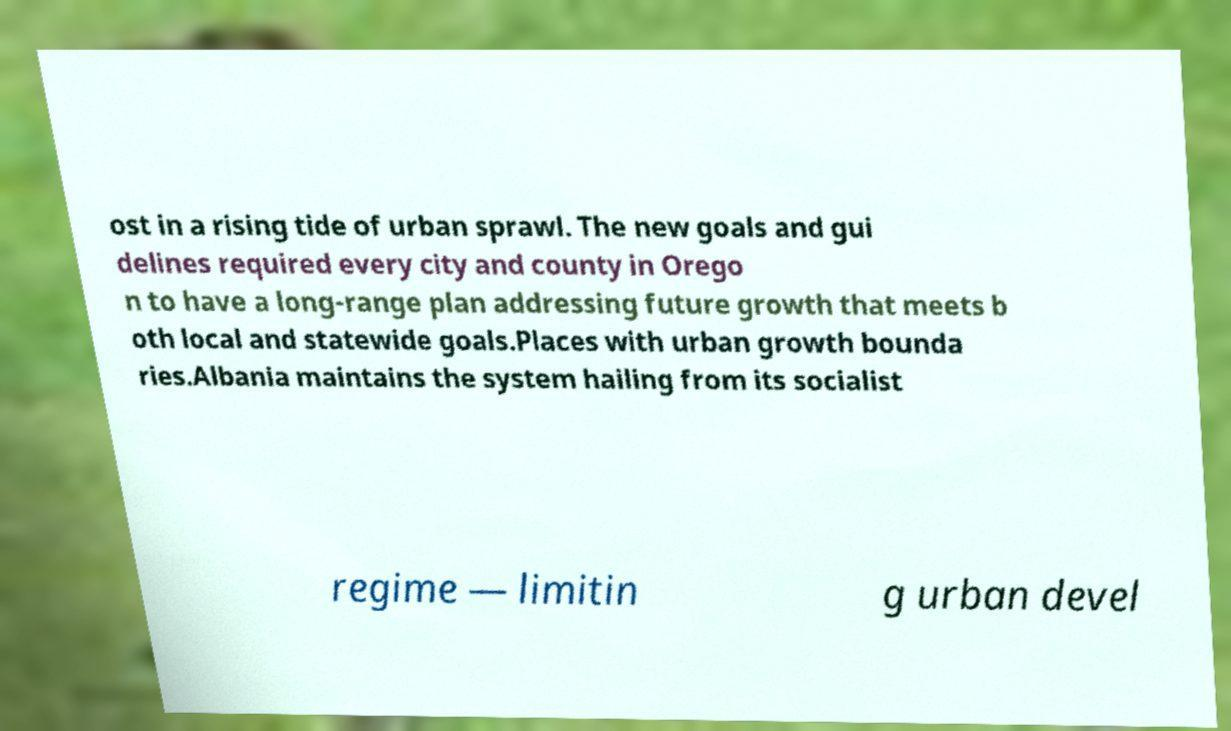What messages or text are displayed in this image? I need them in a readable, typed format. ost in a rising tide of urban sprawl. The new goals and gui delines required every city and county in Orego n to have a long-range plan addressing future growth that meets b oth local and statewide goals.Places with urban growth bounda ries.Albania maintains the system hailing from its socialist regime — limitin g urban devel 